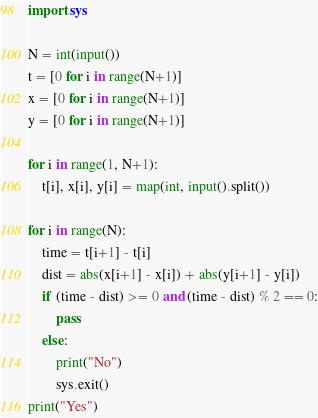Convert code to text. <code><loc_0><loc_0><loc_500><loc_500><_Python_>import sys

N = int(input())
t = [0 for i in range(N+1)]
x = [0 for i in range(N+1)]
y = [0 for i in range(N+1)]

for i in range(1, N+1):
    t[i], x[i], y[i] = map(int, input().split())

for i in range(N):
    time = t[i+1] - t[i]
    dist = abs(x[i+1] - x[i]) + abs(y[i+1] - y[i])
    if (time - dist) >= 0 and (time - dist) % 2 == 0:
        pass
    else:
        print("No")
        sys.exit()
print("Yes")
</code> 